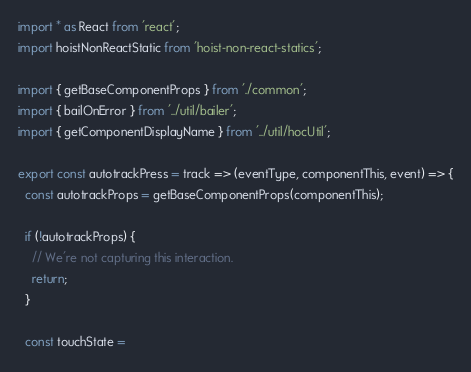Convert code to text. <code><loc_0><loc_0><loc_500><loc_500><_JavaScript_>import * as React from 'react';
import hoistNonReactStatic from 'hoist-non-react-statics';

import { getBaseComponentProps } from './common';
import { bailOnError } from '../util/bailer';
import { getComponentDisplayName } from '../util/hocUtil';

export const autotrackPress = track => (eventType, componentThis, event) => {
  const autotrackProps = getBaseComponentProps(componentThis);

  if (!autotrackProps) {
    // We're not capturing this interaction.
    return;
  }

  const touchState =</code> 